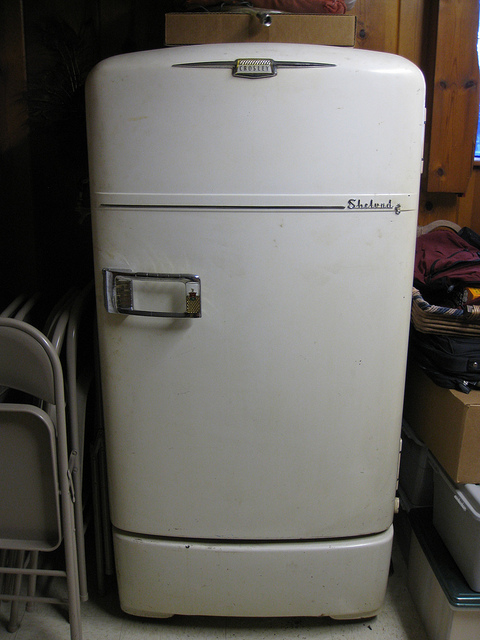<image>What brand is the refrigerator? I don't know what the brand of the refrigerator is. It could be 'shetland', 'she load', 'frigidaire', 'blue lead', 'she lead', 'sledge', 'lakeland', or 'behedge'. What brand is the refrigerator? It is unknown what brand the refrigerator is. Possible options include 'shetland', 'she load', 'frigidaire', 'blue lead', 'she lead', 'sledge', 'lakeland', or 'behedge'. 